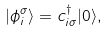<formula> <loc_0><loc_0><loc_500><loc_500>| \phi ^ { \sigma } _ { i } \rangle = c ^ { \dagger } _ { i \sigma } | 0 \rangle ,</formula> 